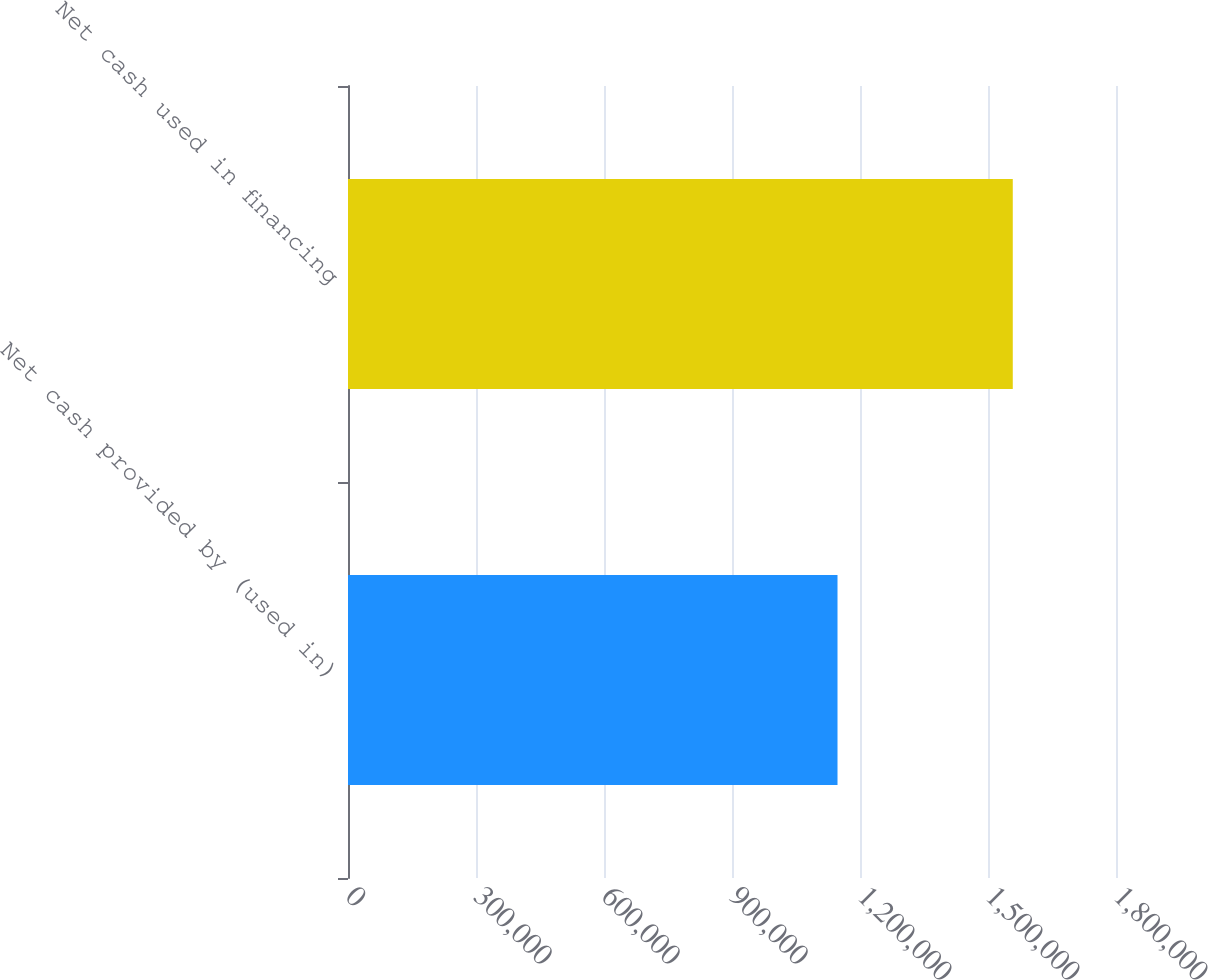<chart> <loc_0><loc_0><loc_500><loc_500><bar_chart><fcel>Net cash provided by (used in)<fcel>Net cash used in financing<nl><fcel>1.14729e+06<fcel>1.55807e+06<nl></chart> 